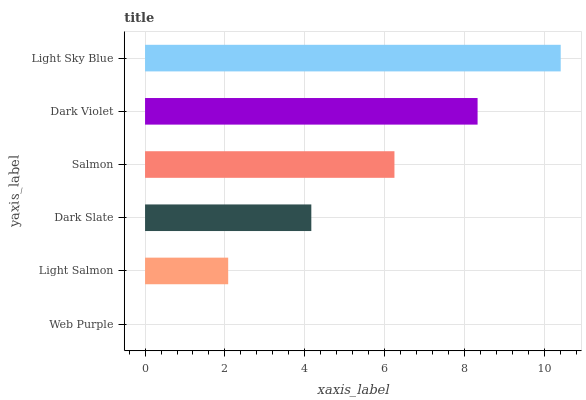Is Web Purple the minimum?
Answer yes or no. Yes. Is Light Sky Blue the maximum?
Answer yes or no. Yes. Is Light Salmon the minimum?
Answer yes or no. No. Is Light Salmon the maximum?
Answer yes or no. No. Is Light Salmon greater than Web Purple?
Answer yes or no. Yes. Is Web Purple less than Light Salmon?
Answer yes or no. Yes. Is Web Purple greater than Light Salmon?
Answer yes or no. No. Is Light Salmon less than Web Purple?
Answer yes or no. No. Is Salmon the high median?
Answer yes or no. Yes. Is Dark Slate the low median?
Answer yes or no. Yes. Is Light Salmon the high median?
Answer yes or no. No. Is Light Salmon the low median?
Answer yes or no. No. 